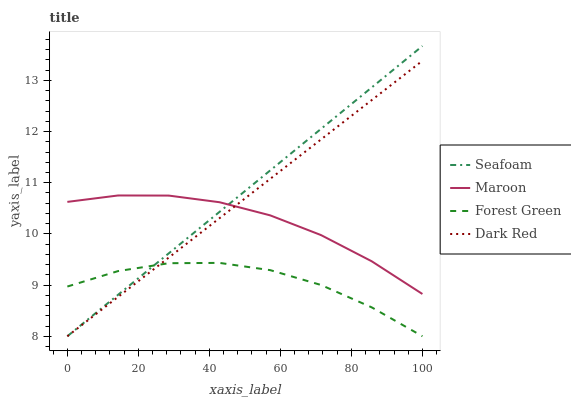Does Forest Green have the minimum area under the curve?
Answer yes or no. Yes. Does Seafoam have the maximum area under the curve?
Answer yes or no. Yes. Does Seafoam have the minimum area under the curve?
Answer yes or no. No. Does Forest Green have the maximum area under the curve?
Answer yes or no. No. Is Dark Red the smoothest?
Answer yes or no. Yes. Is Forest Green the roughest?
Answer yes or no. Yes. Is Seafoam the smoothest?
Answer yes or no. No. Is Seafoam the roughest?
Answer yes or no. No. Does Dark Red have the lowest value?
Answer yes or no. Yes. Does Maroon have the lowest value?
Answer yes or no. No. Does Seafoam have the highest value?
Answer yes or no. Yes. Does Forest Green have the highest value?
Answer yes or no. No. Is Forest Green less than Maroon?
Answer yes or no. Yes. Is Maroon greater than Forest Green?
Answer yes or no. Yes. Does Seafoam intersect Maroon?
Answer yes or no. Yes. Is Seafoam less than Maroon?
Answer yes or no. No. Is Seafoam greater than Maroon?
Answer yes or no. No. Does Forest Green intersect Maroon?
Answer yes or no. No. 